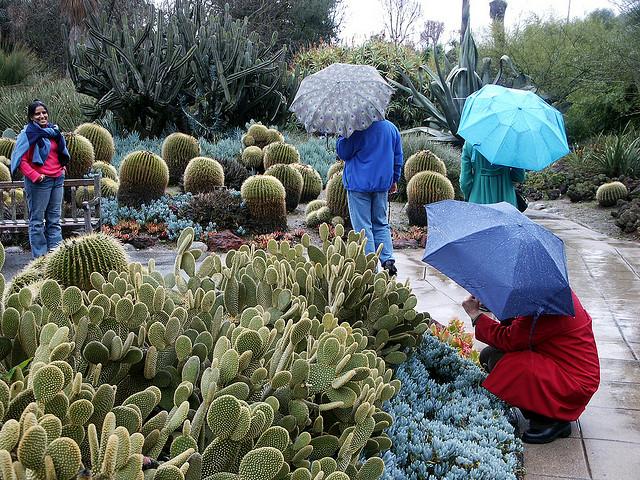Is the person without an umbrella a man?
Be succinct. No. Are more than half of the people in this photo carrying umbrellas?
Give a very brief answer. Yes. What kind of plants are in the lower left of the foreground?
Give a very brief answer. Cactus. 